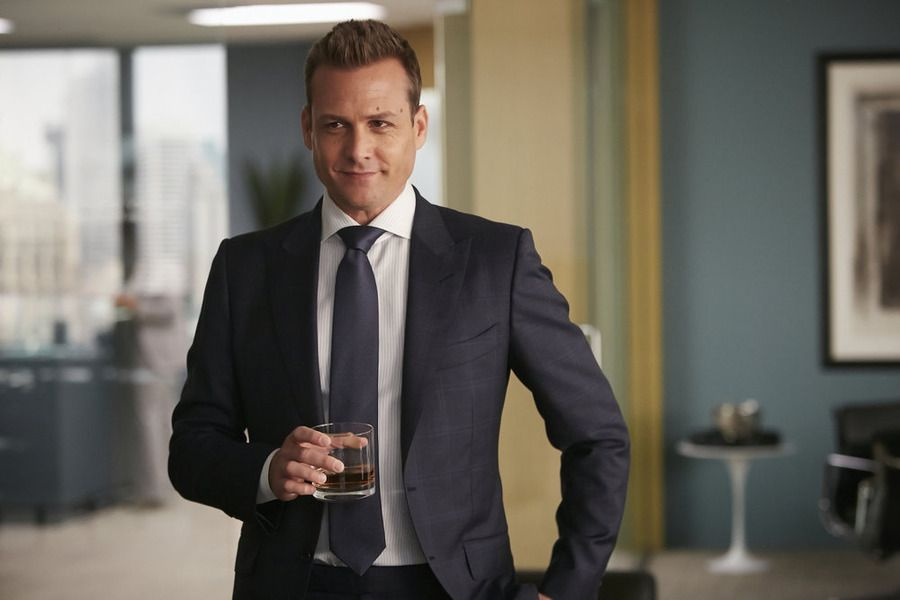If this image was a scene in a thriller, what would happen next? As the man sips his whiskey, the phone on his desk rings. His brow furrows as he picks it up, listening intently. The voice on the other end is urgent, detailing a series of high-stakes maneuvers that threaten to unravel the empire he's built. He must make a crucial decision: trust an old ally who has betrayed him in the past, or take a risky gamble that could either save his company or lead to its downfall. The serene office becomes a battleground of wits and nerve, with shadows of doubt lurking at every turn. The city's lights outside flicker ominously, mirroring the tension within the room. 